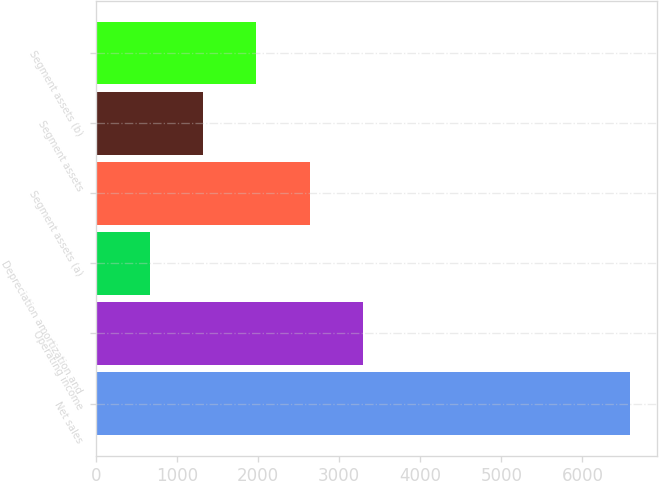Convert chart. <chart><loc_0><loc_0><loc_500><loc_500><bar_chart><fcel>Net sales<fcel>Operating income<fcel>Depreciation amortization and<fcel>Segment assets (a)<fcel>Segment assets<fcel>Segment assets (b)<nl><fcel>6590<fcel>3298<fcel>664.4<fcel>2639.6<fcel>1322.8<fcel>1981.2<nl></chart> 